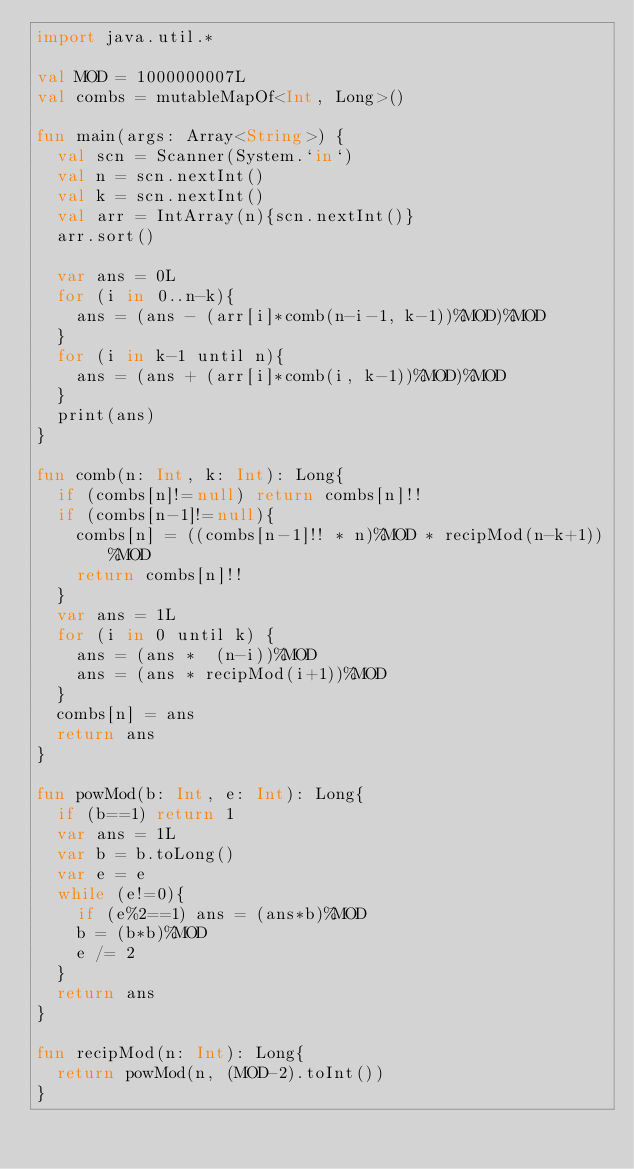<code> <loc_0><loc_0><loc_500><loc_500><_Kotlin_>import java.util.*

val MOD = 1000000007L
val combs = mutableMapOf<Int, Long>()

fun main(args: Array<String>) {
	val scn = Scanner(System.`in`)
	val n = scn.nextInt()
	val k = scn.nextInt()
	val arr = IntArray(n){scn.nextInt()}
	arr.sort()

	var ans = 0L
	for (i in 0..n-k){
		ans = (ans - (arr[i]*comb(n-i-1, k-1))%MOD)%MOD
	}
	for (i in k-1 until n){
		ans = (ans + (arr[i]*comb(i, k-1))%MOD)%MOD
	}
	print(ans)
}

fun comb(n: Int, k: Int): Long{
	if (combs[n]!=null) return combs[n]!!
	if (combs[n-1]!=null){
		combs[n] = ((combs[n-1]!! * n)%MOD * recipMod(n-k+1))%MOD
		return combs[n]!!
	}
	var ans = 1L
	for (i in 0 until k) {
		ans = (ans *  (n-i))%MOD
		ans = (ans * recipMod(i+1))%MOD
	}
	combs[n] = ans
	return ans
}

fun powMod(b: Int, e: Int): Long{
	if (b==1) return 1
	var ans = 1L
	var b = b.toLong()
	var e = e
	while (e!=0){
		if (e%2==1) ans = (ans*b)%MOD
		b = (b*b)%MOD
		e /= 2
	}
	return ans
}

fun recipMod(n: Int): Long{
	return powMod(n, (MOD-2).toInt())
}</code> 